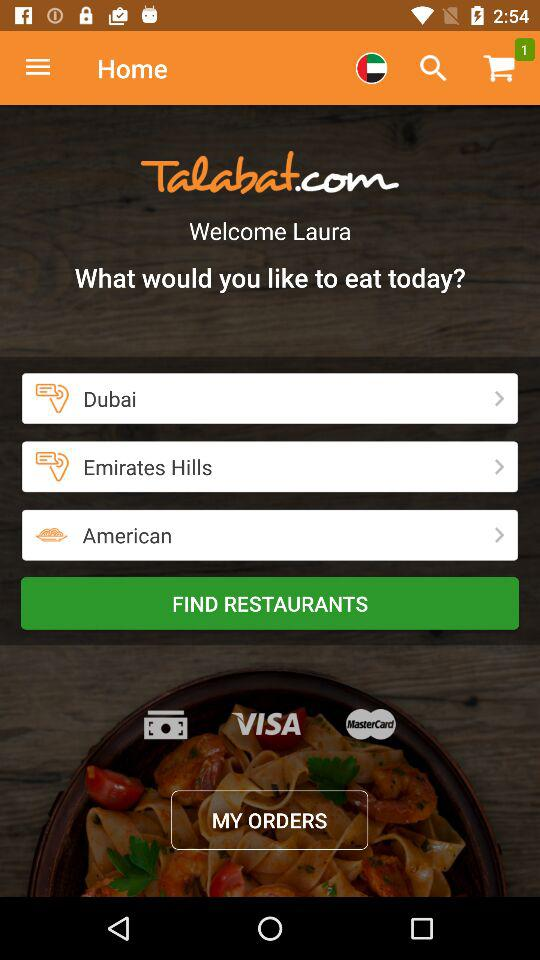How many items are there in the cart? There is 1 item. 